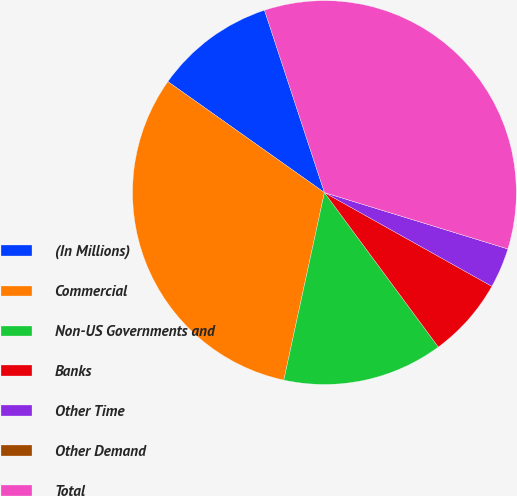Convert chart to OTSL. <chart><loc_0><loc_0><loc_500><loc_500><pie_chart><fcel>(In Millions)<fcel>Commercial<fcel>Non-US Governments and<fcel>Banks<fcel>Other Time<fcel>Other Demand<fcel>Total<nl><fcel>10.13%<fcel>31.42%<fcel>13.51%<fcel>6.76%<fcel>3.38%<fcel>0.0%<fcel>34.8%<nl></chart> 